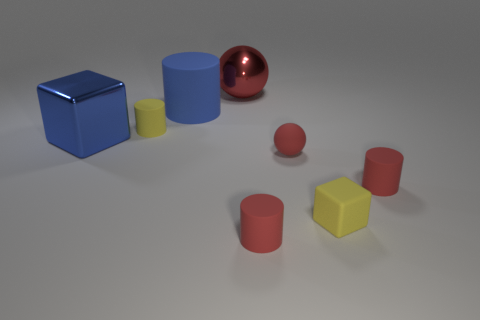There is another ball that is the same color as the large metal sphere; what material is it?
Offer a very short reply. Rubber. Is the red object behind the large matte thing made of the same material as the tiny thing that is behind the large cube?
Your response must be concise. No. Is the color of the large ball the same as the tiny sphere?
Your response must be concise. Yes. How many tiny balls are the same color as the large shiny ball?
Offer a very short reply. 1. The large red thing behind the small rubber cylinder behind the large object that is in front of the small yellow matte cylinder is made of what material?
Keep it short and to the point. Metal. What size is the red matte thing right of the yellow rubber object that is in front of the red cylinder that is behind the small yellow cube?
Make the answer very short. Small. There is a object that is behind the big blue metal block and right of the blue cylinder; how big is it?
Ensure brevity in your answer.  Large. Do the thing to the right of the yellow block and the cylinder in front of the yellow cube have the same color?
Offer a very short reply. Yes. What number of rubber cylinders are on the left side of the small red matte sphere?
Ensure brevity in your answer.  3. Is there a red matte cylinder that is behind the small thing left of the red object behind the yellow rubber cylinder?
Offer a terse response. No. 